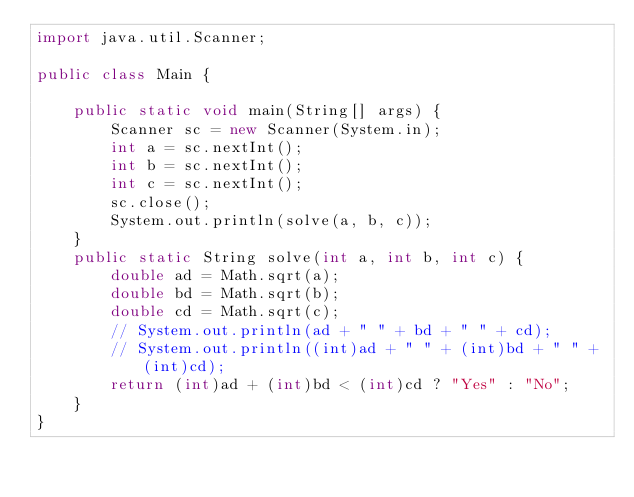Convert code to text. <code><loc_0><loc_0><loc_500><loc_500><_Java_>import java.util.Scanner;

public class Main {

	public static void main(String[] args) {
		Scanner sc = new Scanner(System.in);
		int a = sc.nextInt();
		int b = sc.nextInt();
		int c = sc.nextInt();
		sc.close();
		System.out.println(solve(a, b, c));
	}
	public static String solve(int a, int b, int c) {
		double ad = Math.sqrt(a);
		double bd = Math.sqrt(b);
		double cd = Math.sqrt(c);
		// System.out.println(ad + " " + bd + " " + cd);
		// System.out.println((int)ad + " " + (int)bd + " " + (int)cd);
		return (int)ad + (int)bd < (int)cd ? "Yes" : "No";
	}
}
</code> 